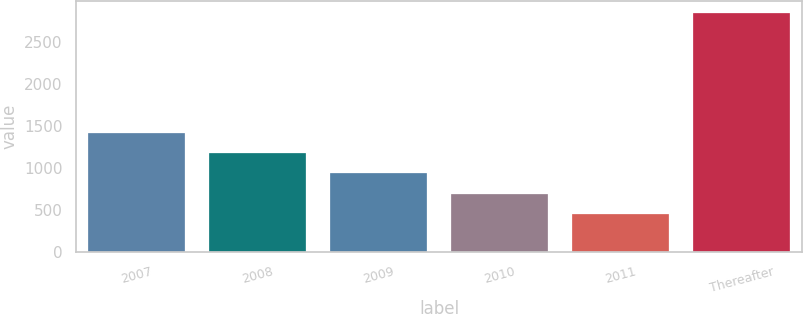Convert chart to OTSL. <chart><loc_0><loc_0><loc_500><loc_500><bar_chart><fcel>2007<fcel>2008<fcel>2009<fcel>2010<fcel>2011<fcel>Thereafter<nl><fcel>1413.2<fcel>1174.4<fcel>935.6<fcel>696.8<fcel>458<fcel>2846<nl></chart> 